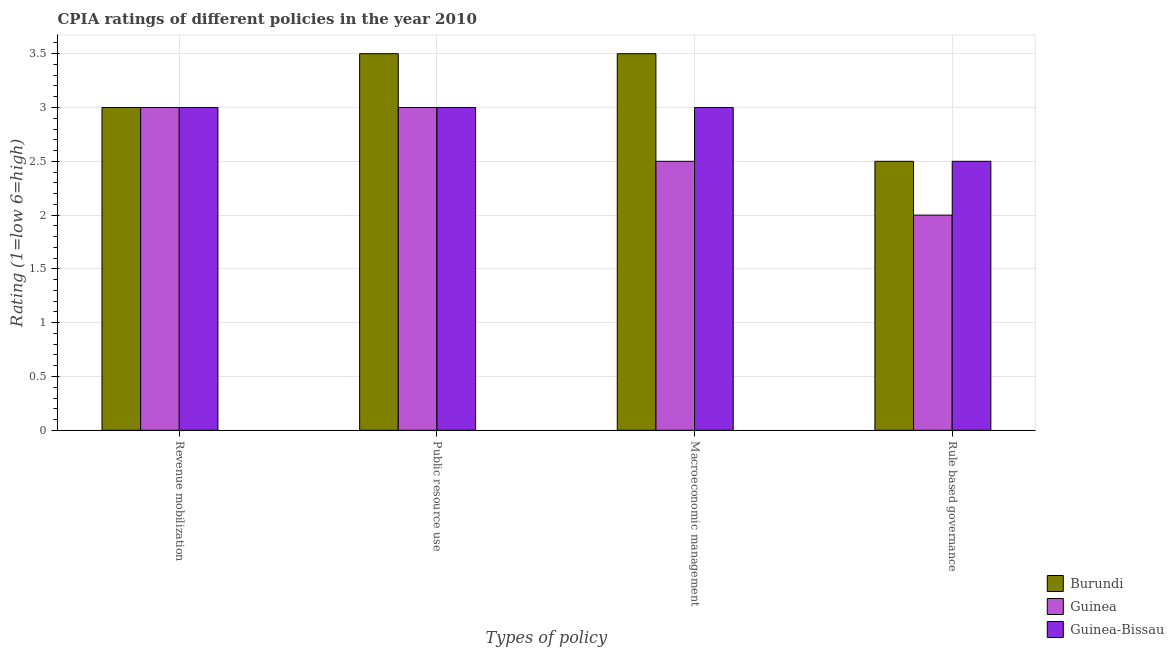How many different coloured bars are there?
Make the answer very short. 3. Are the number of bars on each tick of the X-axis equal?
Ensure brevity in your answer.  Yes. How many bars are there on the 4th tick from the right?
Your answer should be very brief. 3. What is the label of the 1st group of bars from the left?
Provide a succinct answer. Revenue mobilization. What is the cpia rating of revenue mobilization in Guinea?
Give a very brief answer. 3. In which country was the cpia rating of rule based governance maximum?
Your response must be concise. Burundi. In which country was the cpia rating of rule based governance minimum?
Offer a very short reply. Guinea. What is the total cpia rating of rule based governance in the graph?
Ensure brevity in your answer.  7. What is the average cpia rating of public resource use per country?
Ensure brevity in your answer.  3.17. In how many countries, is the cpia rating of public resource use greater than 1.9 ?
Ensure brevity in your answer.  3. What is the ratio of the cpia rating of rule based governance in Guinea-Bissau to that in Burundi?
Your answer should be very brief. 1. Is the cpia rating of macroeconomic management in Burundi less than that in Guinea-Bissau?
Ensure brevity in your answer.  No. What is the difference between the highest and the second highest cpia rating of public resource use?
Offer a very short reply. 0.5. What is the difference between the highest and the lowest cpia rating of macroeconomic management?
Your answer should be compact. 1. In how many countries, is the cpia rating of revenue mobilization greater than the average cpia rating of revenue mobilization taken over all countries?
Your answer should be compact. 0. Is it the case that in every country, the sum of the cpia rating of rule based governance and cpia rating of public resource use is greater than the sum of cpia rating of revenue mobilization and cpia rating of macroeconomic management?
Give a very brief answer. No. What does the 3rd bar from the left in Macroeconomic management represents?
Offer a terse response. Guinea-Bissau. What does the 3rd bar from the right in Public resource use represents?
Your answer should be compact. Burundi. How many bars are there?
Offer a very short reply. 12. Are all the bars in the graph horizontal?
Ensure brevity in your answer.  No. How many countries are there in the graph?
Provide a short and direct response. 3. What is the difference between two consecutive major ticks on the Y-axis?
Offer a terse response. 0.5. Are the values on the major ticks of Y-axis written in scientific E-notation?
Provide a short and direct response. No. Does the graph contain grids?
Ensure brevity in your answer.  Yes. Where does the legend appear in the graph?
Offer a terse response. Bottom right. What is the title of the graph?
Provide a short and direct response. CPIA ratings of different policies in the year 2010. Does "Sub-Saharan Africa (all income levels)" appear as one of the legend labels in the graph?
Your answer should be compact. No. What is the label or title of the X-axis?
Your response must be concise. Types of policy. What is the label or title of the Y-axis?
Provide a succinct answer. Rating (1=low 6=high). What is the Rating (1=low 6=high) of Burundi in Revenue mobilization?
Your answer should be very brief. 3. What is the Rating (1=low 6=high) in Guinea-Bissau in Revenue mobilization?
Your response must be concise. 3. What is the Rating (1=low 6=high) of Guinea in Macroeconomic management?
Your answer should be compact. 2.5. What is the Rating (1=low 6=high) in Guinea-Bissau in Macroeconomic management?
Offer a terse response. 3. What is the Rating (1=low 6=high) in Guinea-Bissau in Rule based governance?
Ensure brevity in your answer.  2.5. Across all Types of policy, what is the maximum Rating (1=low 6=high) in Guinea-Bissau?
Offer a terse response. 3. Across all Types of policy, what is the minimum Rating (1=low 6=high) in Guinea-Bissau?
Give a very brief answer. 2.5. What is the total Rating (1=low 6=high) of Burundi in the graph?
Your response must be concise. 12.5. What is the total Rating (1=low 6=high) of Guinea-Bissau in the graph?
Give a very brief answer. 11.5. What is the difference between the Rating (1=low 6=high) in Burundi in Revenue mobilization and that in Public resource use?
Your answer should be compact. -0.5. What is the difference between the Rating (1=low 6=high) of Guinea in Revenue mobilization and that in Public resource use?
Ensure brevity in your answer.  0. What is the difference between the Rating (1=low 6=high) of Burundi in Revenue mobilization and that in Macroeconomic management?
Make the answer very short. -0.5. What is the difference between the Rating (1=low 6=high) of Guinea-Bissau in Revenue mobilization and that in Macroeconomic management?
Provide a short and direct response. 0. What is the difference between the Rating (1=low 6=high) in Burundi in Revenue mobilization and that in Rule based governance?
Make the answer very short. 0.5. What is the difference between the Rating (1=low 6=high) in Guinea in Revenue mobilization and that in Rule based governance?
Your answer should be compact. 1. What is the difference between the Rating (1=low 6=high) in Burundi in Public resource use and that in Macroeconomic management?
Ensure brevity in your answer.  0. What is the difference between the Rating (1=low 6=high) of Burundi in Public resource use and that in Rule based governance?
Give a very brief answer. 1. What is the difference between the Rating (1=low 6=high) in Burundi in Revenue mobilization and the Rating (1=low 6=high) in Guinea-Bissau in Public resource use?
Your answer should be very brief. 0. What is the difference between the Rating (1=low 6=high) in Burundi in Revenue mobilization and the Rating (1=low 6=high) in Guinea in Macroeconomic management?
Your answer should be very brief. 0.5. What is the difference between the Rating (1=low 6=high) in Burundi in Revenue mobilization and the Rating (1=low 6=high) in Guinea-Bissau in Rule based governance?
Keep it short and to the point. 0.5. What is the difference between the Rating (1=low 6=high) in Burundi in Public resource use and the Rating (1=low 6=high) in Guinea-Bissau in Macroeconomic management?
Make the answer very short. 0.5. What is the difference between the Rating (1=low 6=high) of Guinea in Public resource use and the Rating (1=low 6=high) of Guinea-Bissau in Macroeconomic management?
Offer a terse response. 0. What is the difference between the Rating (1=low 6=high) in Burundi in Public resource use and the Rating (1=low 6=high) in Guinea in Rule based governance?
Offer a terse response. 1.5. What is the difference between the Rating (1=low 6=high) in Burundi in Public resource use and the Rating (1=low 6=high) in Guinea-Bissau in Rule based governance?
Offer a very short reply. 1. What is the average Rating (1=low 6=high) of Burundi per Types of policy?
Keep it short and to the point. 3.12. What is the average Rating (1=low 6=high) in Guinea per Types of policy?
Your answer should be very brief. 2.62. What is the average Rating (1=low 6=high) of Guinea-Bissau per Types of policy?
Offer a very short reply. 2.88. What is the difference between the Rating (1=low 6=high) in Burundi and Rating (1=low 6=high) in Guinea in Revenue mobilization?
Make the answer very short. 0. What is the difference between the Rating (1=low 6=high) of Guinea and Rating (1=low 6=high) of Guinea-Bissau in Revenue mobilization?
Make the answer very short. 0. What is the difference between the Rating (1=low 6=high) of Guinea and Rating (1=low 6=high) of Guinea-Bissau in Public resource use?
Your answer should be compact. 0. What is the difference between the Rating (1=low 6=high) of Burundi and Rating (1=low 6=high) of Guinea-Bissau in Macroeconomic management?
Provide a short and direct response. 0.5. What is the difference between the Rating (1=low 6=high) of Guinea and Rating (1=low 6=high) of Guinea-Bissau in Macroeconomic management?
Your answer should be very brief. -0.5. What is the ratio of the Rating (1=low 6=high) of Burundi in Revenue mobilization to that in Public resource use?
Offer a terse response. 0.86. What is the ratio of the Rating (1=low 6=high) in Guinea-Bissau in Revenue mobilization to that in Public resource use?
Give a very brief answer. 1. What is the ratio of the Rating (1=low 6=high) in Burundi in Revenue mobilization to that in Macroeconomic management?
Ensure brevity in your answer.  0.86. What is the ratio of the Rating (1=low 6=high) in Burundi in Revenue mobilization to that in Rule based governance?
Keep it short and to the point. 1.2. What is the ratio of the Rating (1=low 6=high) of Guinea in Revenue mobilization to that in Rule based governance?
Give a very brief answer. 1.5. What is the ratio of the Rating (1=low 6=high) in Burundi in Public resource use to that in Macroeconomic management?
Offer a terse response. 1. What is the ratio of the Rating (1=low 6=high) in Guinea in Public resource use to that in Macroeconomic management?
Keep it short and to the point. 1.2. What is the ratio of the Rating (1=low 6=high) in Burundi in Public resource use to that in Rule based governance?
Ensure brevity in your answer.  1.4. What is the ratio of the Rating (1=low 6=high) of Guinea in Public resource use to that in Rule based governance?
Your answer should be compact. 1.5. What is the ratio of the Rating (1=low 6=high) of Guinea-Bissau in Public resource use to that in Rule based governance?
Offer a terse response. 1.2. What is the ratio of the Rating (1=low 6=high) in Burundi in Macroeconomic management to that in Rule based governance?
Keep it short and to the point. 1.4. What is the ratio of the Rating (1=low 6=high) in Guinea-Bissau in Macroeconomic management to that in Rule based governance?
Keep it short and to the point. 1.2. What is the difference between the highest and the second highest Rating (1=low 6=high) of Burundi?
Offer a very short reply. 0. What is the difference between the highest and the second highest Rating (1=low 6=high) in Guinea?
Offer a terse response. 0. What is the difference between the highest and the second highest Rating (1=low 6=high) in Guinea-Bissau?
Your response must be concise. 0. What is the difference between the highest and the lowest Rating (1=low 6=high) of Guinea?
Give a very brief answer. 1. 